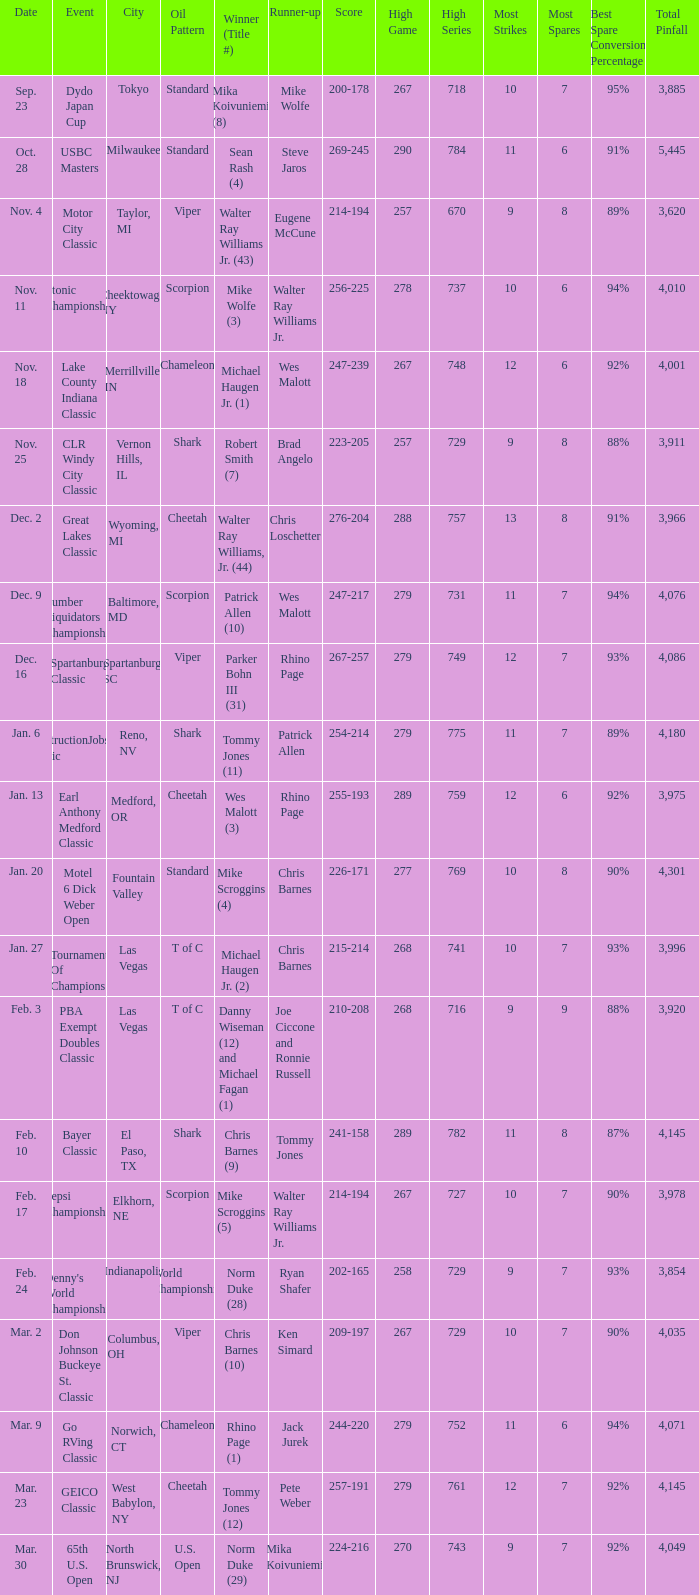Name the Date which has a Oil Pattern of chameleon, and a Event of lake county indiana classic? Nov. 18. 